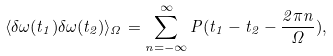Convert formula to latex. <formula><loc_0><loc_0><loc_500><loc_500>\langle \delta \omega ( t _ { 1 } ) \delta \omega ( t _ { 2 } ) \rangle _ { \Omega } = \sum _ { n = - \infty } ^ { \infty } P ( t _ { 1 } - t _ { 2 } - \frac { 2 \pi n } { \Omega } ) ,</formula> 